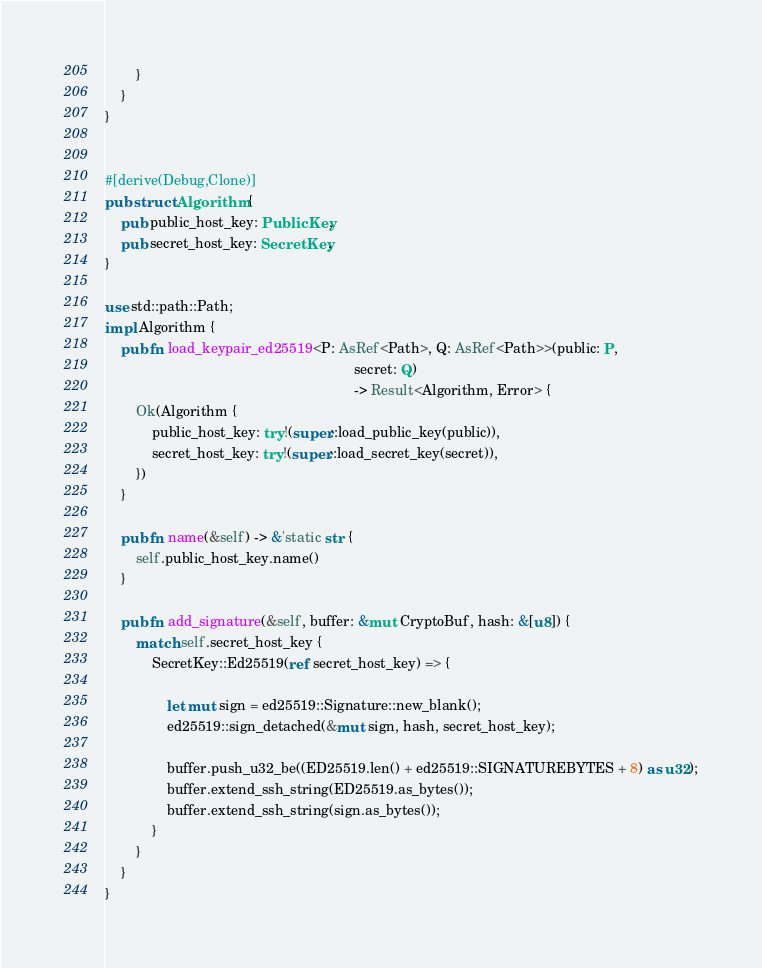Convert code to text. <code><loc_0><loc_0><loc_500><loc_500><_Rust_>        }
    }
}


#[derive(Debug,Clone)]
pub struct Algorithm {
    pub public_host_key: PublicKey,
    pub secret_host_key: SecretKey,
}

use std::path::Path;
impl Algorithm {
    pub fn load_keypair_ed25519<P: AsRef<Path>, Q: AsRef<Path>>(public: P,
                                                                secret: Q)
                                                                -> Result<Algorithm, Error> {
        Ok(Algorithm {
            public_host_key: try!(super::load_public_key(public)),
            secret_host_key: try!(super::load_secret_key(secret)),
        })
    }

    pub fn name(&self) -> &'static str {
        self.public_host_key.name()
    }

    pub fn add_signature(&self, buffer: &mut CryptoBuf, hash: &[u8]) {
        match self.secret_host_key {
            SecretKey::Ed25519(ref secret_host_key) => {

                let mut sign = ed25519::Signature::new_blank();
                ed25519::sign_detached(&mut sign, hash, secret_host_key);

                buffer.push_u32_be((ED25519.len() + ed25519::SIGNATUREBYTES + 8) as u32);
                buffer.extend_ssh_string(ED25519.as_bytes());
                buffer.extend_ssh_string(sign.as_bytes());
            }
        }
    }
}
</code> 